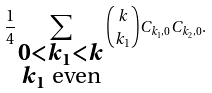<formula> <loc_0><loc_0><loc_500><loc_500>\frac { 1 } { 4 } \sum _ { \substack { 0 < k _ { 1 } < k \\ k _ { 1 } \text { even} } } \binom { k } { k _ { 1 } } C _ { k _ { 1 } , 0 } C _ { k _ { 2 } , 0 } .</formula> 